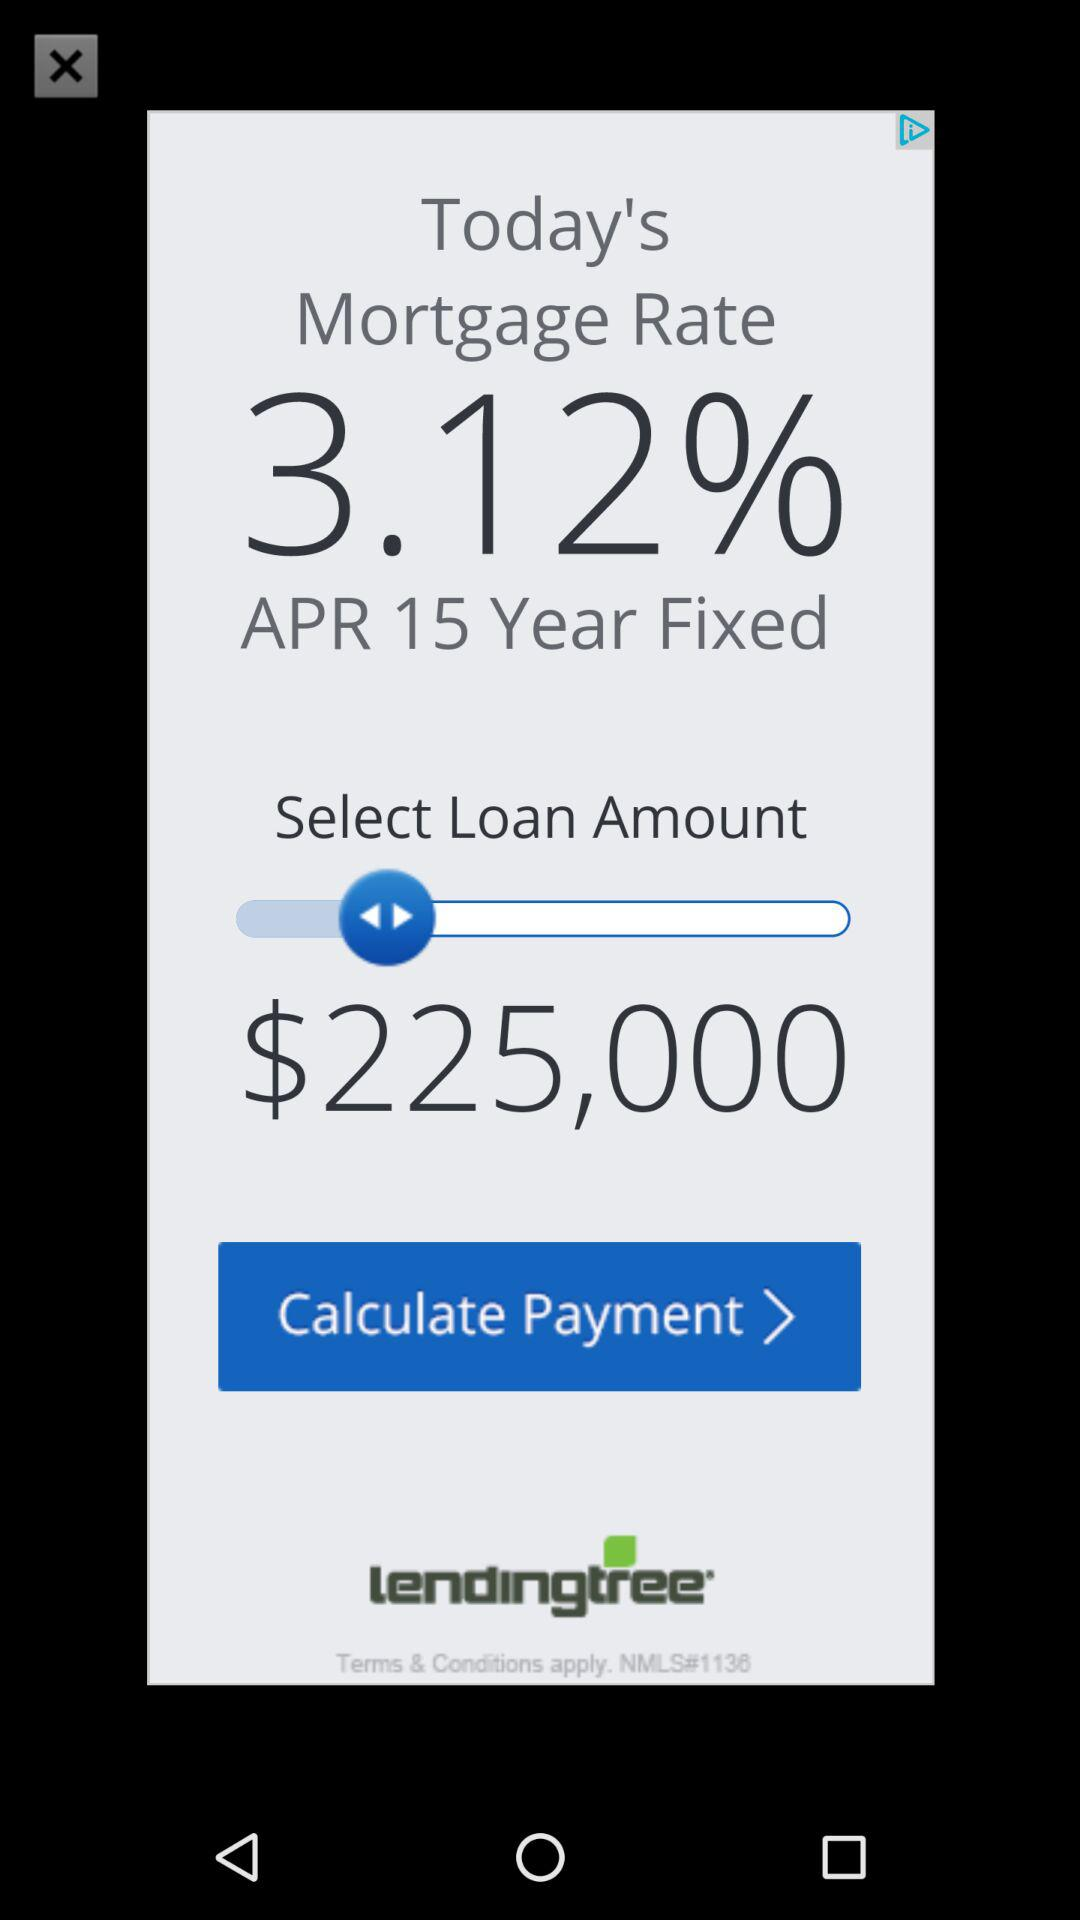How many years is the loan term?
Answer the question using a single word or phrase. 15 years 